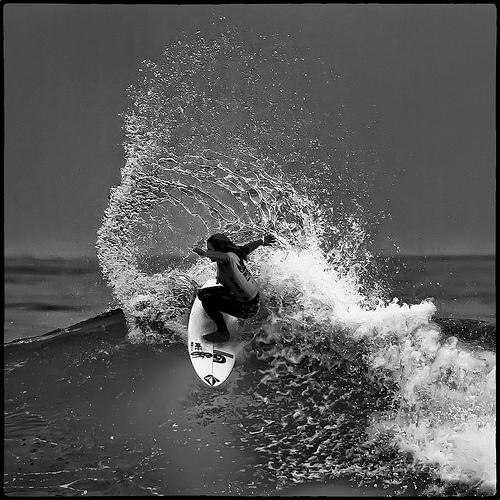Question: why is the man in the water?
Choices:
A. To surf.
B. To fish.
C. To swim.
D. To rescue dog.
Answer with the letter. Answer: A Question: what color is the picture?
Choices:
A. Yellow and red.
B. Green and blue.
C. Purple and gold.
D. Black and white.
Answer with the letter. Answer: D Question: what is wet?
Choices:
A. The grass.
B. The snow.
C. The ocean.
D. The mopped floor.
Answer with the letter. Answer: C Question: when is this taken?
Choices:
A. During the day.
B. At noon.
C. At midnight.
D. In the evening.
Answer with the letter. Answer: A 